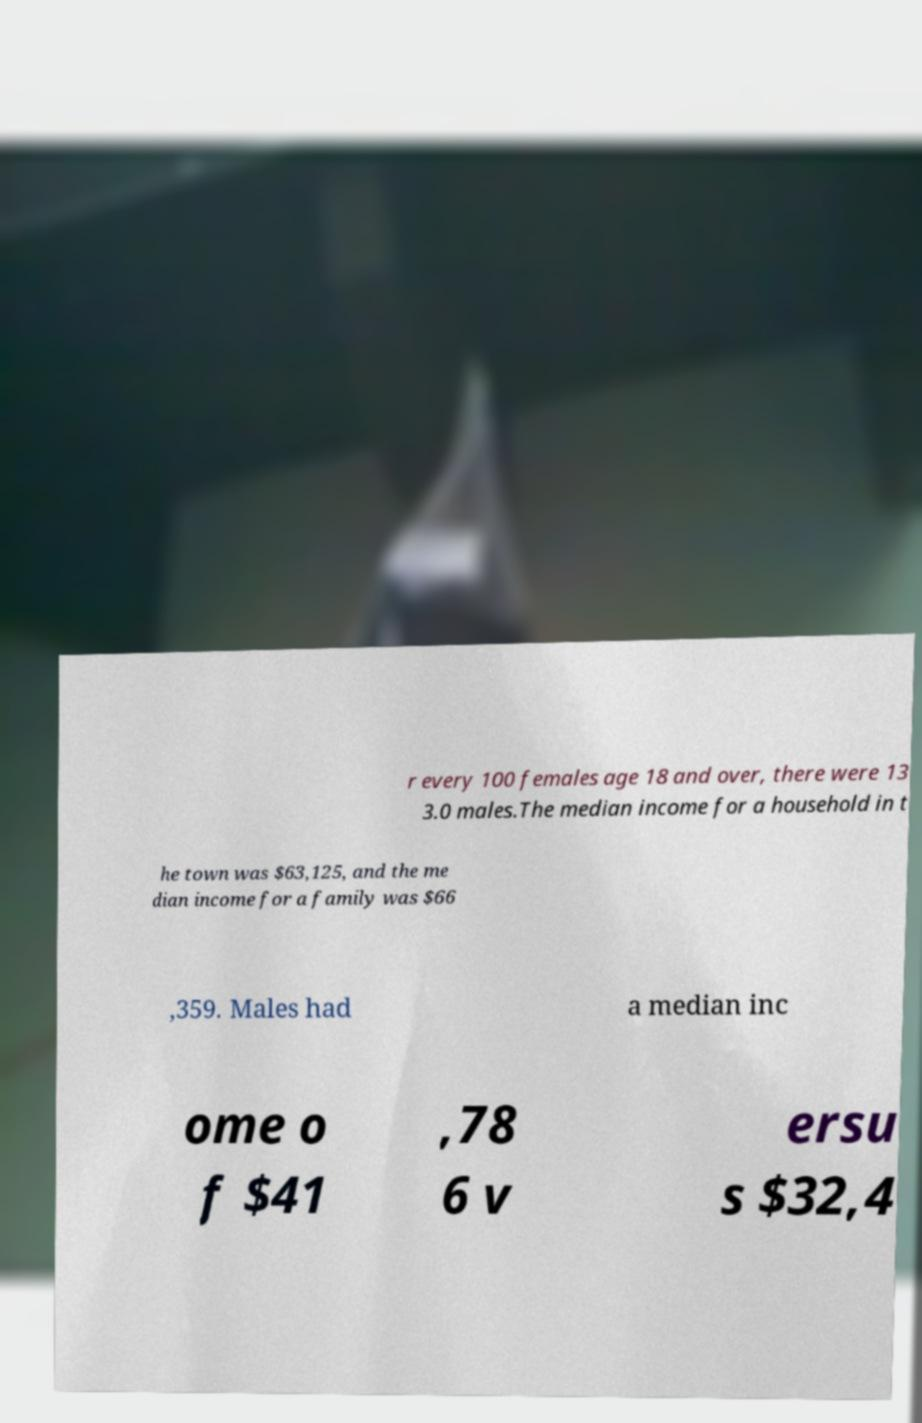Can you read and provide the text displayed in the image?This photo seems to have some interesting text. Can you extract and type it out for me? r every 100 females age 18 and over, there were 13 3.0 males.The median income for a household in t he town was $63,125, and the me dian income for a family was $66 ,359. Males had a median inc ome o f $41 ,78 6 v ersu s $32,4 